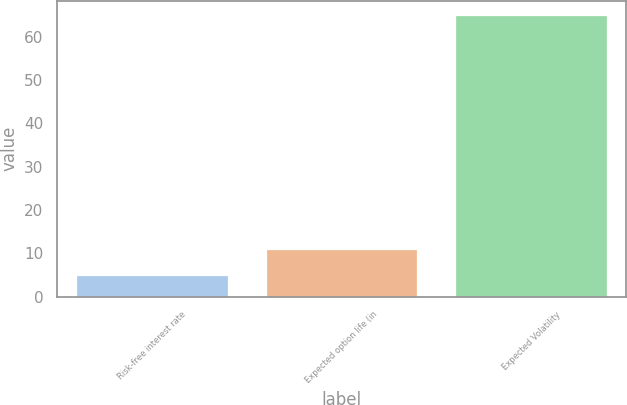Convert chart to OTSL. <chart><loc_0><loc_0><loc_500><loc_500><bar_chart><fcel>Risk-free interest rate<fcel>Expected option life (in<fcel>Expected Volatility<nl><fcel>4.97<fcel>10.97<fcel>65<nl></chart> 